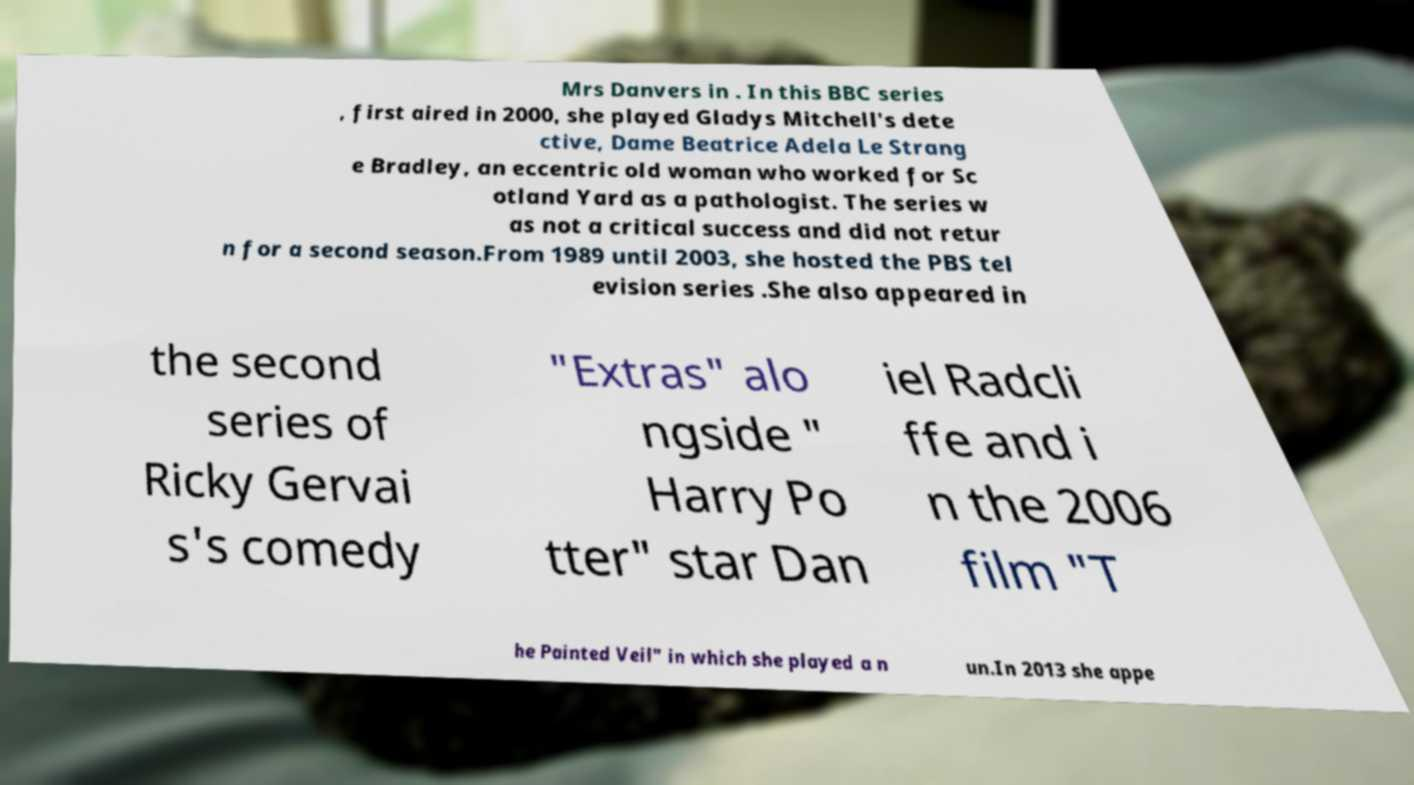Can you accurately transcribe the text from the provided image for me? Mrs Danvers in . In this BBC series , first aired in 2000, she played Gladys Mitchell's dete ctive, Dame Beatrice Adela Le Strang e Bradley, an eccentric old woman who worked for Sc otland Yard as a pathologist. The series w as not a critical success and did not retur n for a second season.From 1989 until 2003, she hosted the PBS tel evision series .She also appeared in the second series of Ricky Gervai s's comedy "Extras" alo ngside " Harry Po tter" star Dan iel Radcli ffe and i n the 2006 film "T he Painted Veil" in which she played a n un.In 2013 she appe 